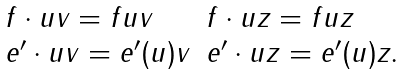<formula> <loc_0><loc_0><loc_500><loc_500>\begin{array} { l l } f \cdot u v = f u v & f \cdot u z = f u z \\ e ^ { \prime } \cdot u v = e ^ { \prime } ( u ) v & e ^ { \prime } \cdot u z = e ^ { \prime } ( u ) z . \end{array}</formula> 